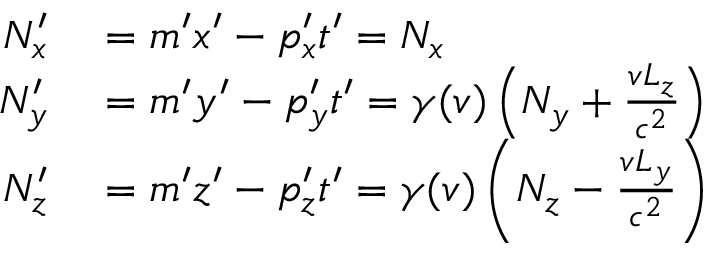<formula> <loc_0><loc_0><loc_500><loc_500>\begin{array} { r l } { N _ { x } ^ { \prime } } & = m ^ { \prime } x ^ { \prime } - p _ { x } ^ { \prime } t ^ { \prime } = N _ { x } } \\ { N _ { y } ^ { \prime } } & = m ^ { \prime } y ^ { \prime } - p _ { y } ^ { \prime } t ^ { \prime } = \gamma ( v ) \left ( N _ { y } + { \frac { v L _ { z } } { c ^ { 2 } } } \right ) } \\ { N _ { z } ^ { \prime } } & = m ^ { \prime } z ^ { \prime } - p _ { z } ^ { \prime } t ^ { \prime } = \gamma ( v ) \left ( N _ { z } - { \frac { v L _ { y } } { c ^ { 2 } } } \right ) } \end{array}</formula> 